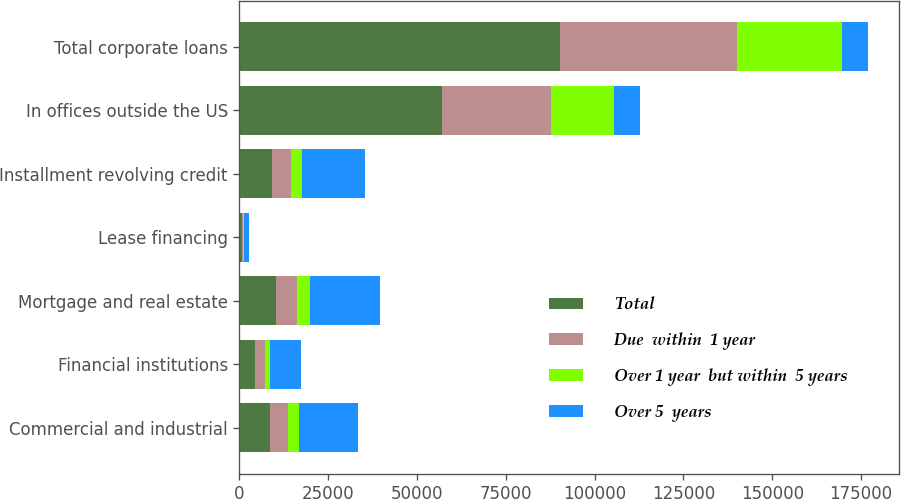<chart> <loc_0><loc_0><loc_500><loc_500><stacked_bar_chart><ecel><fcel>Commercial and industrial<fcel>Financial institutions<fcel>Mortgage and real estate<fcel>Lease financing<fcel>Installment revolving credit<fcel>In offices outside the US<fcel>Total corporate loans<nl><fcel>Total<fcel>8661<fcel>4516<fcel>10255<fcel>674<fcel>9211<fcel>56997<fcel>90314<nl><fcel>Due  within  1 year<fcel>4944<fcel>2577<fcel>5854<fcel>384<fcel>5257<fcel>30674<fcel>49690<nl><fcel>Over 1 year  but within  5 years<fcel>3073<fcel>1602<fcel>3639<fcel>239<fcel>3269<fcel>17895<fcel>29717<nl><fcel>Over 5  years<fcel>16678<fcel>8695<fcel>19748<fcel>1297<fcel>17737<fcel>7257.5<fcel>7257.5<nl></chart> 